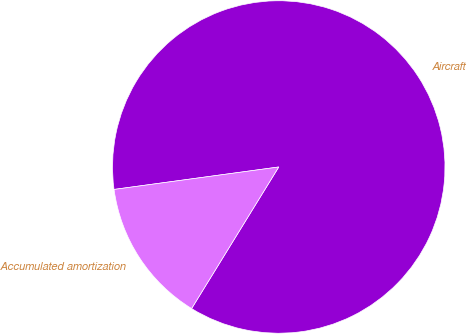<chart> <loc_0><loc_0><loc_500><loc_500><pie_chart><fcel>Aircraft<fcel>Accumulated amortization<nl><fcel>85.94%<fcel>14.06%<nl></chart> 